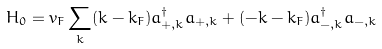Convert formula to latex. <formula><loc_0><loc_0><loc_500><loc_500>H _ { 0 } = v _ { F } \sum _ { k } ( k - k _ { F } ) a ^ { \dag } _ { + , k } a _ { + , k } + ( - k - k _ { F } ) a ^ { \dag } _ { - , k } a _ { - , k }</formula> 